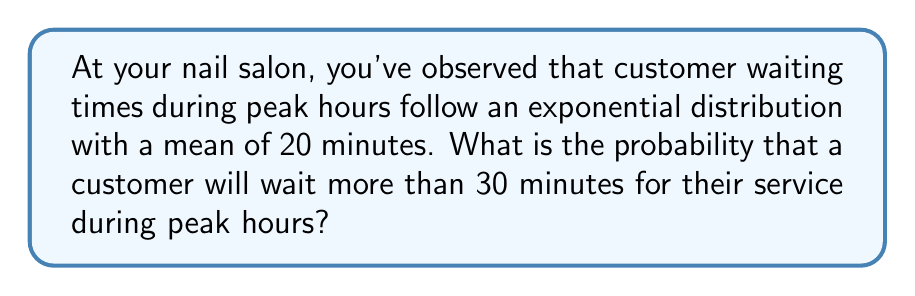Can you solve this math problem? Let's approach this step-by-step:

1) The waiting time $X$ follows an exponential distribution with mean $\mu = 20$ minutes.

2) For an exponential distribution, the rate parameter $\lambda$ is the inverse of the mean:

   $\lambda = \frac{1}{\mu} = \frac{1}{20} = 0.05$ per minute

3) We want to find $P(X > 30)$, the probability that the waiting time exceeds 30 minutes.

4) For an exponential distribution, the cumulative distribution function (CDF) is:

   $F(x) = 1 - e^{-\lambda x}$

5) Therefore, the probability of waiting more than $x$ minutes is:

   $P(X > x) = 1 - F(x) = e^{-\lambda x}$

6) Substituting our values:

   $P(X > 30) = e^{-0.05 * 30} = e^{-1.5}$

7) Using a calculator or computer:

   $e^{-1.5} \approx 0.2231$

Thus, the probability of a customer waiting more than 30 minutes is approximately 0.2231 or 22.31%.
Answer: $e^{-1.5} \approx 0.2231$ or 22.31% 